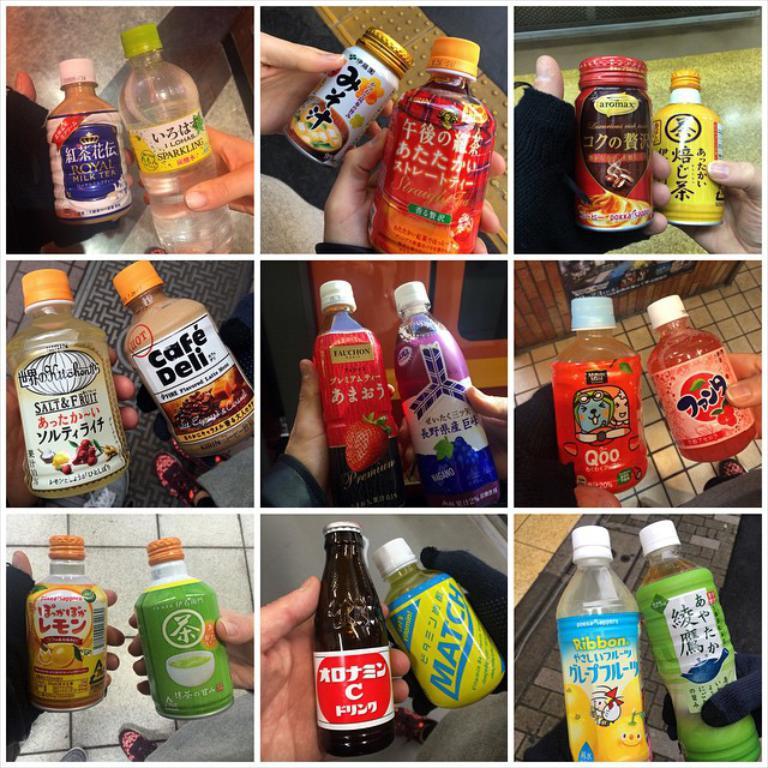What is the other half of the cafe name on the bottle with the orange cap?
Ensure brevity in your answer.  Deli. What kind of milk tea is in the top left bottle?
Your answer should be very brief. Royal. 